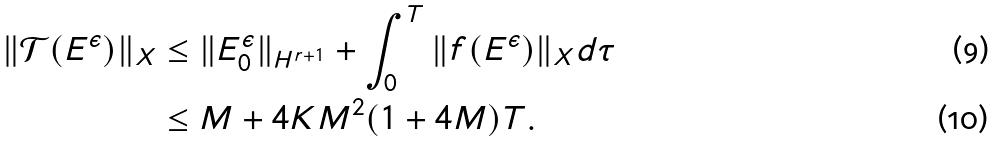<formula> <loc_0><loc_0><loc_500><loc_500>\| \mathcal { T } ( E ^ { \epsilon } ) \| _ { X } & \leq \| E ^ { \epsilon } _ { 0 } \| _ { H ^ { r + 1 } } + \int _ { 0 } ^ { T } \| f ( E ^ { \epsilon } ) \| _ { X } d \tau \\ & \leq M + 4 K M ^ { 2 } ( 1 + 4 M ) T .</formula> 